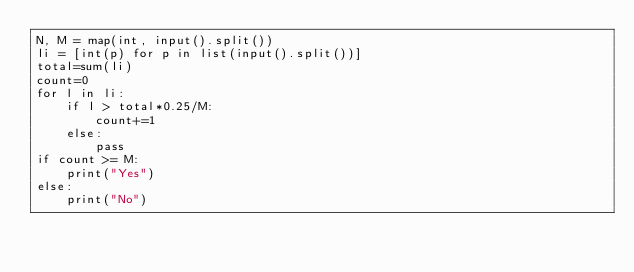Convert code to text. <code><loc_0><loc_0><loc_500><loc_500><_Python_>N, M = map(int, input().split())
li = [int(p) for p in list(input().split())]
total=sum(li)
count=0
for l in li:
    if l > total*0.25/M:
        count+=1
    else:
        pass
if count >= M:
    print("Yes")
else:
    print("No")</code> 